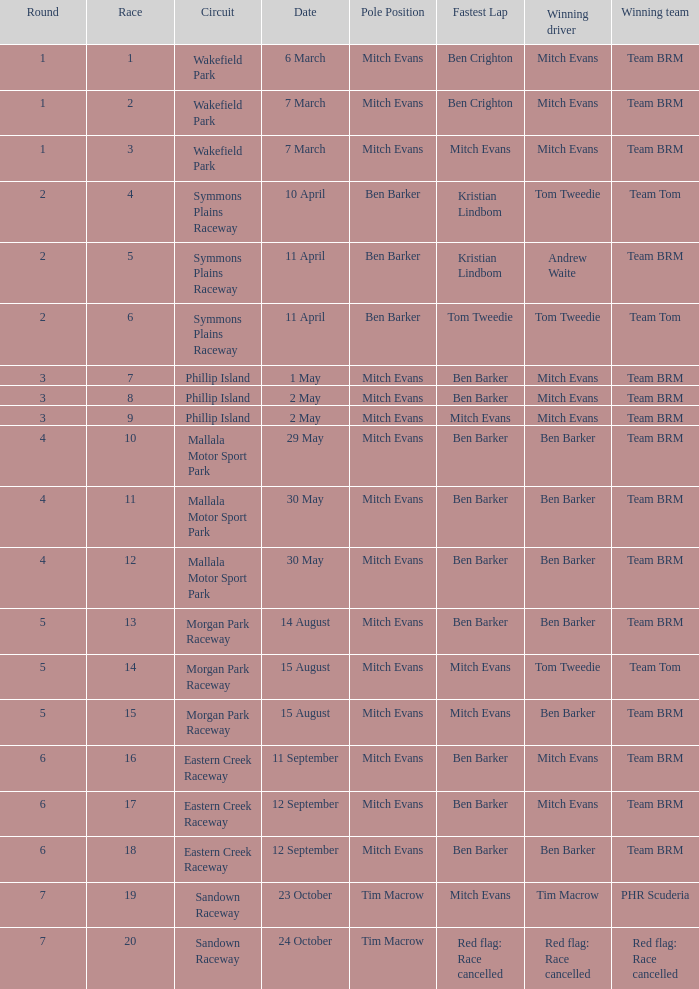In how many stages was race 17? 1.0. 